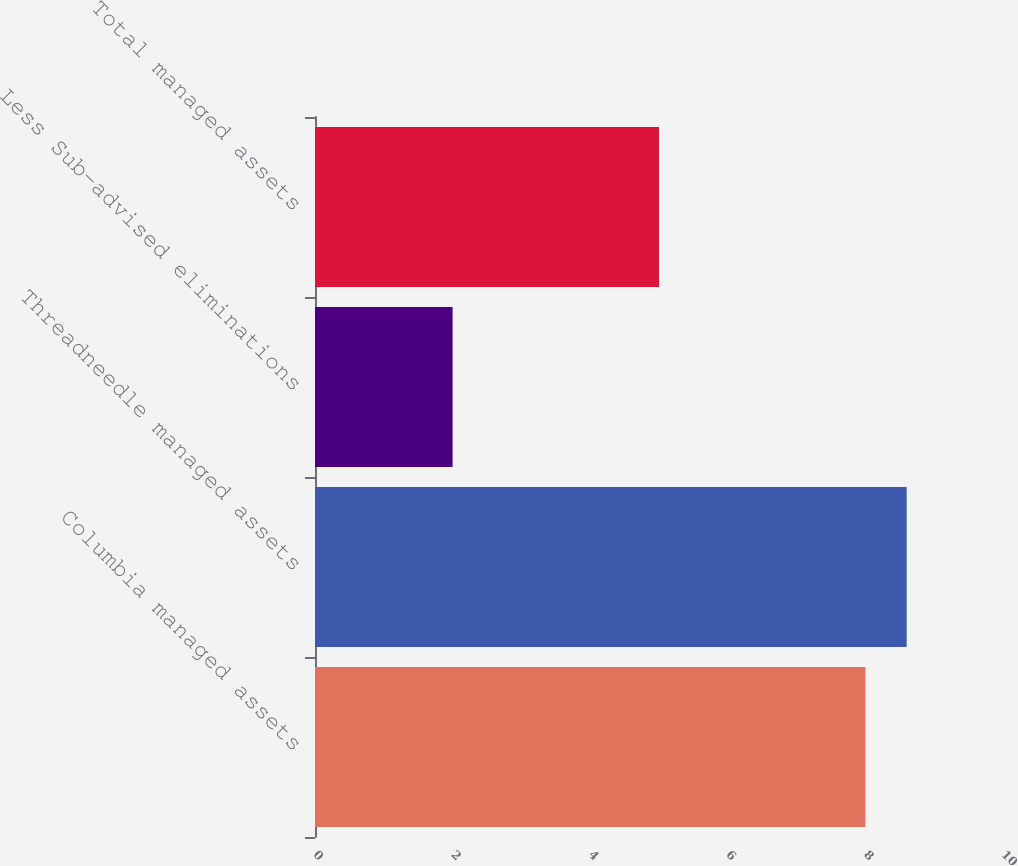Convert chart. <chart><loc_0><loc_0><loc_500><loc_500><bar_chart><fcel>Columbia managed assets<fcel>Threadneedle managed assets<fcel>Less Sub-advised eliminations<fcel>Total managed assets<nl><fcel>8<fcel>8.6<fcel>2<fcel>5<nl></chart> 